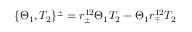<formula> <loc_0><loc_0><loc_500><loc_500>\{ \Theta _ { 1 } , T _ { 2 } \} ^ { \pm } = r _ { \pm } ^ { 1 2 } \Theta _ { 1 } T _ { 2 } - \Theta _ { 1 } r _ { \mp } ^ { 1 2 } T _ { 2 }</formula> 